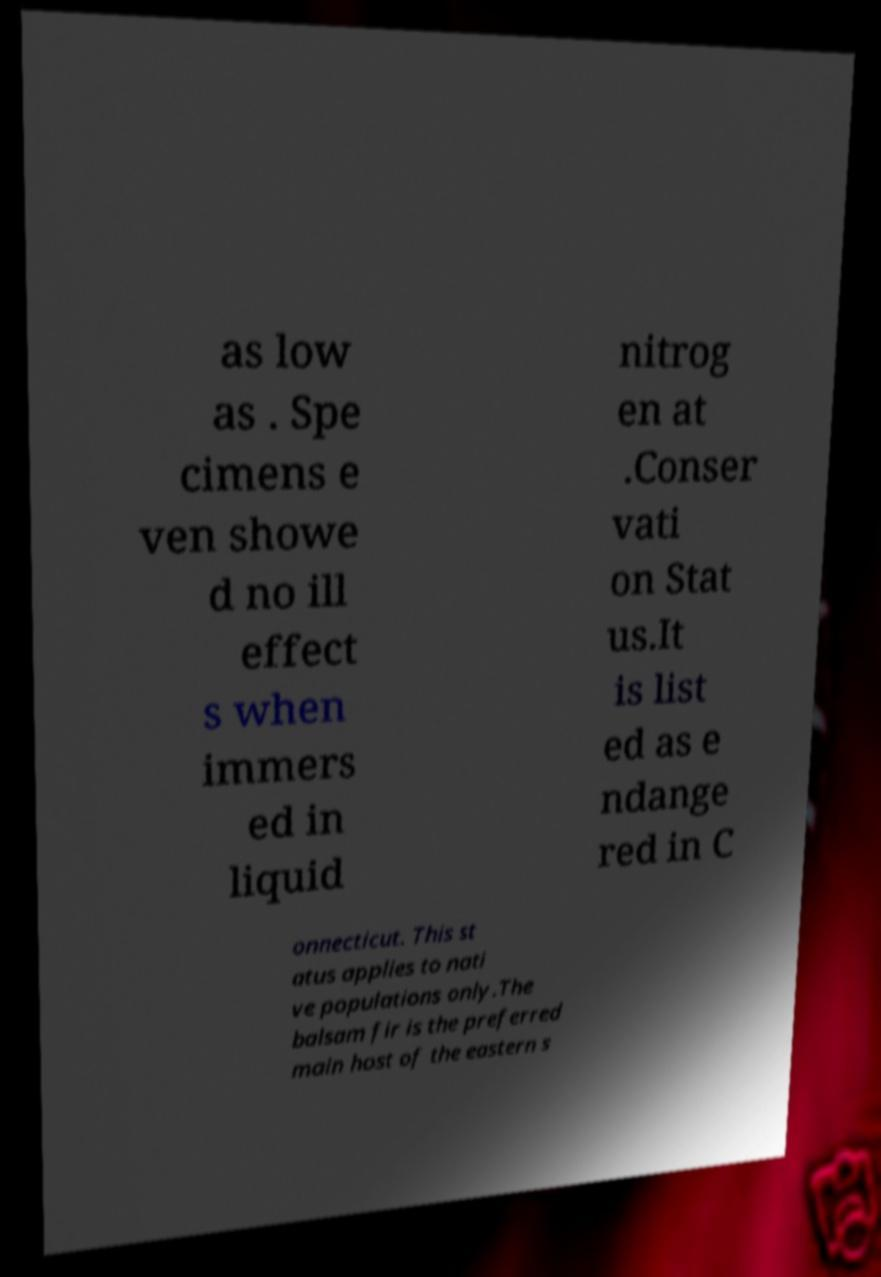For documentation purposes, I need the text within this image transcribed. Could you provide that? as low as . Spe cimens e ven showe d no ill effect s when immers ed in liquid nitrog en at .Conser vati on Stat us.It is list ed as e ndange red in C onnecticut. This st atus applies to nati ve populations only.The balsam fir is the preferred main host of the eastern s 